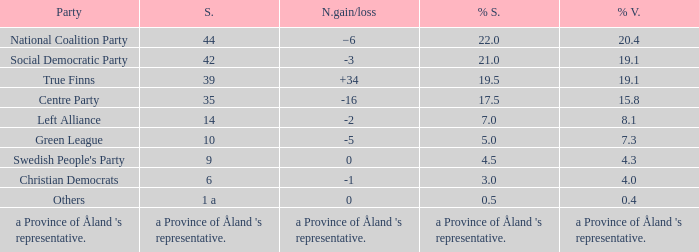When the Swedish People's Party had a net gain/loss of 0, how many seats did they have? 9.0. 